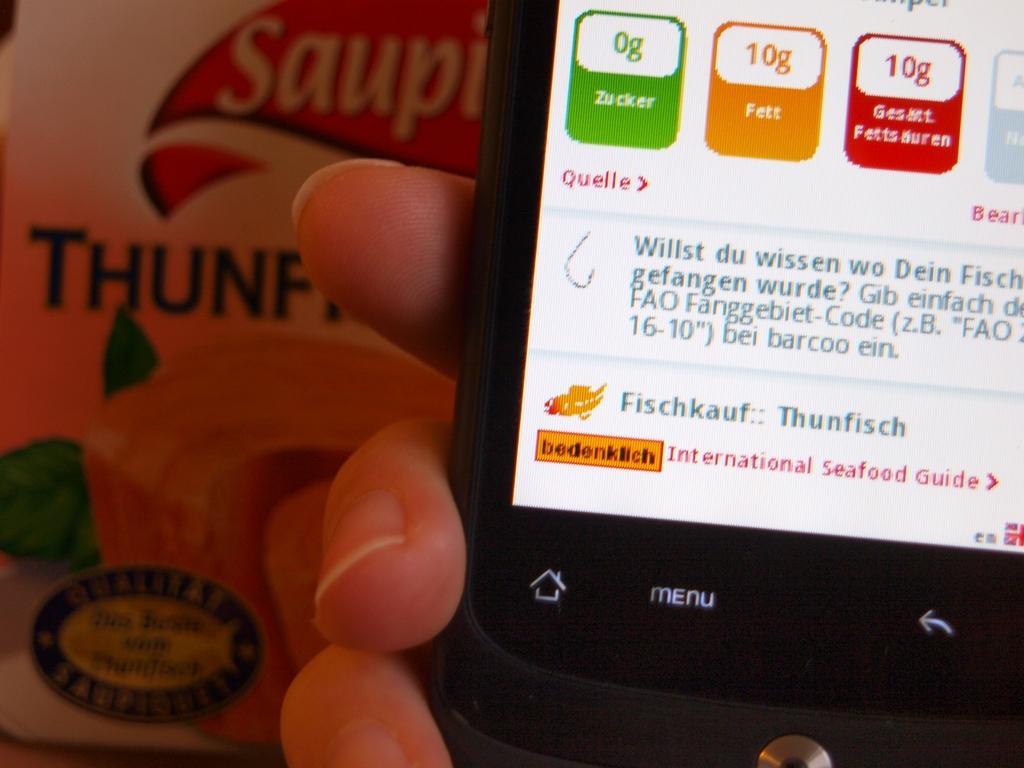<image>
Share a concise interpretation of the image provided. a phone with the name zucker on a green part 